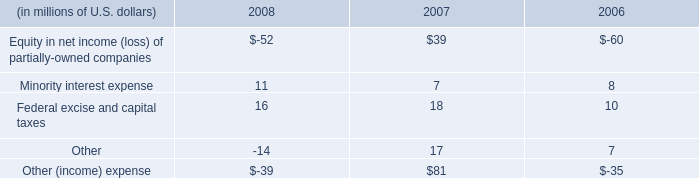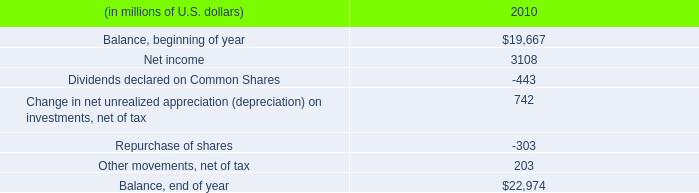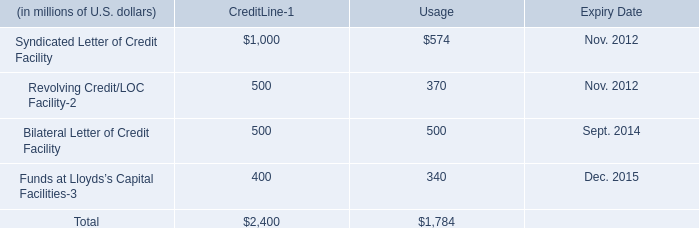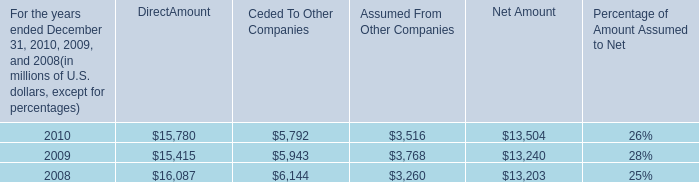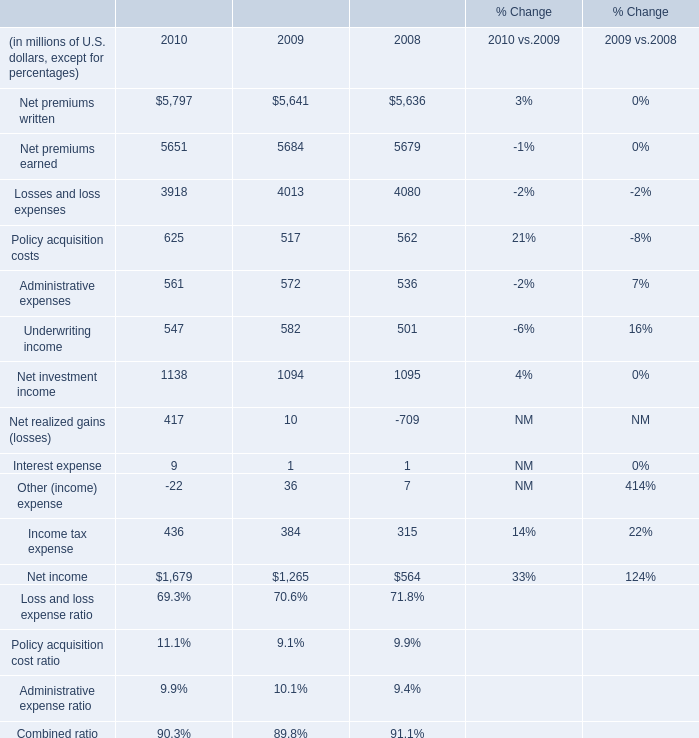What's the total amount of the Other (income) expense in the years where Losses and loss expenses is greater than 4020? (in million) 
Computations: (((-52 + 11) + 16) - 14)
Answer: -39.0. 